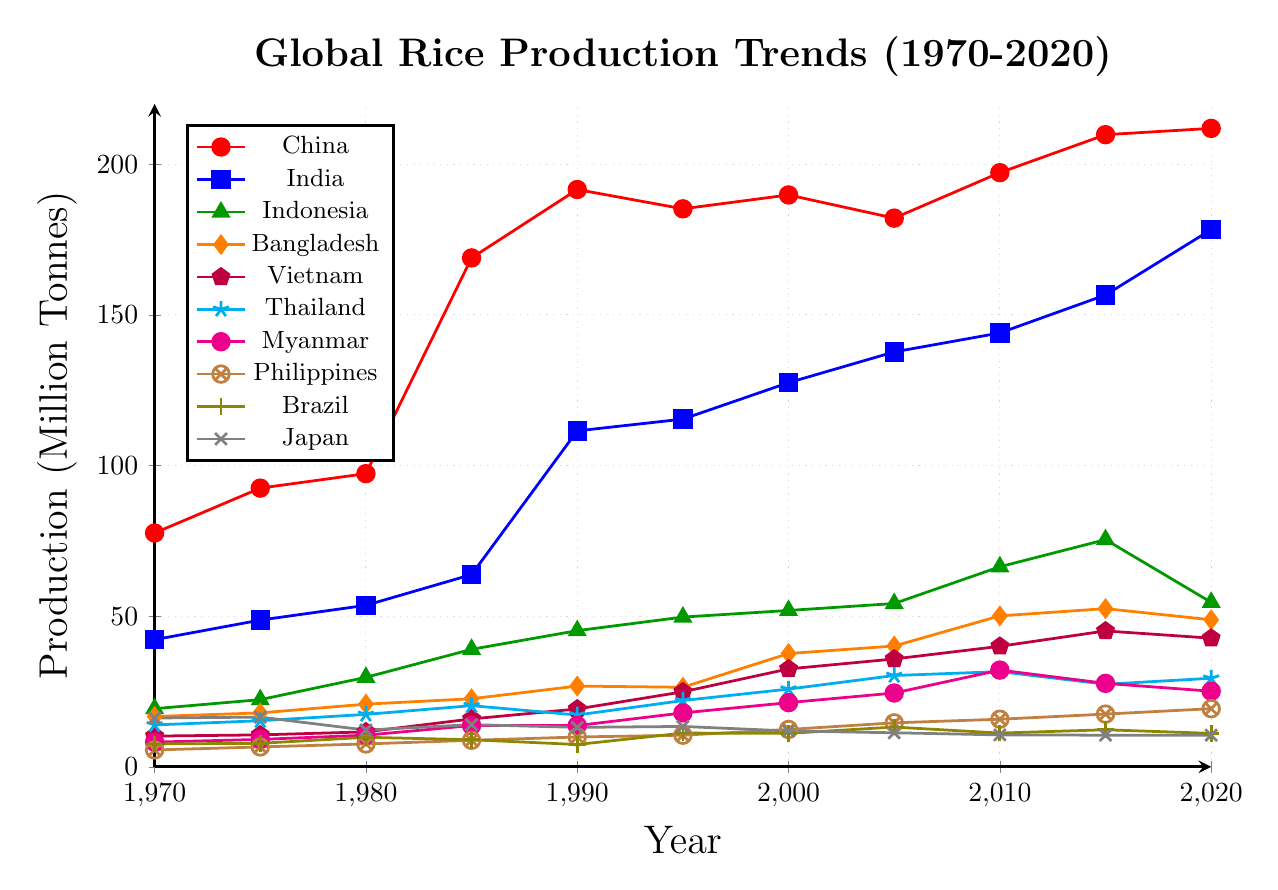Which country had the highest rice production in 2020? The red line representing China is the highest among all lines for the year 2020.
Answer: China How did rice production in India change from 1970 to 2020? The line for India (blue) shows an increasing trend from 42.2 million tonnes in 1970 to 178.3 million tonnes in 2020.
Answer: Increased What was the difference in rice production between China and India in 2020? Rice production in China in 2020 was 211.9 million tonnes, and in India, it was 178.3 million tonnes. The difference is 211.9 - 178.3 = 33.6 million tonnes.
Answer: 33.6 million tonnes Which country showed a notable drop in rice production around 1980 and then another in 2020? The gray line representing Japan dropped around 1980 from 16.5 to 12.2 million tonnes and later from 2015 to 2020 where it remained constant at around 10.5 million tonnes.
Answer: Japan Which two countries had the closest rice production values in 2005? In 2005, Brazil (13.2) and Japan (11.3) had values within about 2 million tonnes of each other.
Answer: Brazil and Japan Among the shown countries, which one had the smallest increase in rice production from 1970 to 2020? The line for Japan (gray) shows little increase from 16.2 million tonnes in 1970 to 10.5 million tonnes in 2020. In fact, it actually decreased.
Answer: Japan What was the average rice production of Vietnam from 1970 to 2020? The production values for Vietnam are: 10.2, 10.6, 11.6, 15.9, 19.2, 24.9, 32.5, 35.8, 40, 45.1, 42.7. Their sum is 288.5. The average is 288.5 / 11 ≈ 26.23 million tonnes.
Answer: 26.23 million tonnes Which year did China see its biggest jump in rice production and by how much? From 1980 to 1985, China's production jumped from 97.3 to 168.9 million tonnes, an increase of 168.9 - 97.3 = 71.6 million tonnes.
Answer: 1985, 71.6 million tonnes 